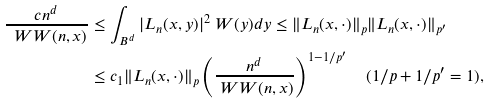Convert formula to latex. <formula><loc_0><loc_0><loc_500><loc_500>\frac { c n ^ { d } } { \ W W ( n , x ) } & \leq \int _ { B ^ { d } } | L _ { n } ( x , y ) | ^ { 2 } \ W ( y ) d y \leq \| L _ { n } ( x , \cdot ) \| _ { p } \| L _ { n } ( x , \cdot ) \| _ { p ^ { \prime } } \\ & \leq c _ { 1 } \| L _ { n } ( x , \cdot ) \| _ { p } \left ( \frac { n ^ { d } } { \ W W ( n , x ) } \right ) ^ { 1 - 1 / p ^ { \prime } } \quad ( 1 / p + 1 / p ^ { \prime } = 1 ) ,</formula> 